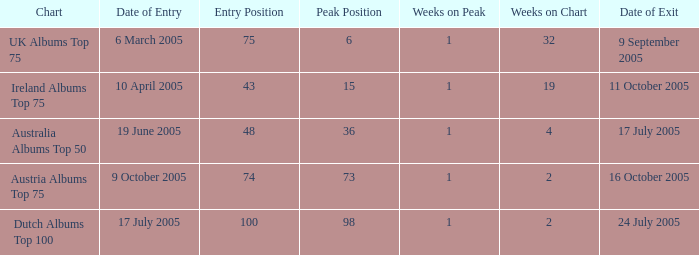What is the ending date for the dutch albums top 100 chart? 24 July 2005. 